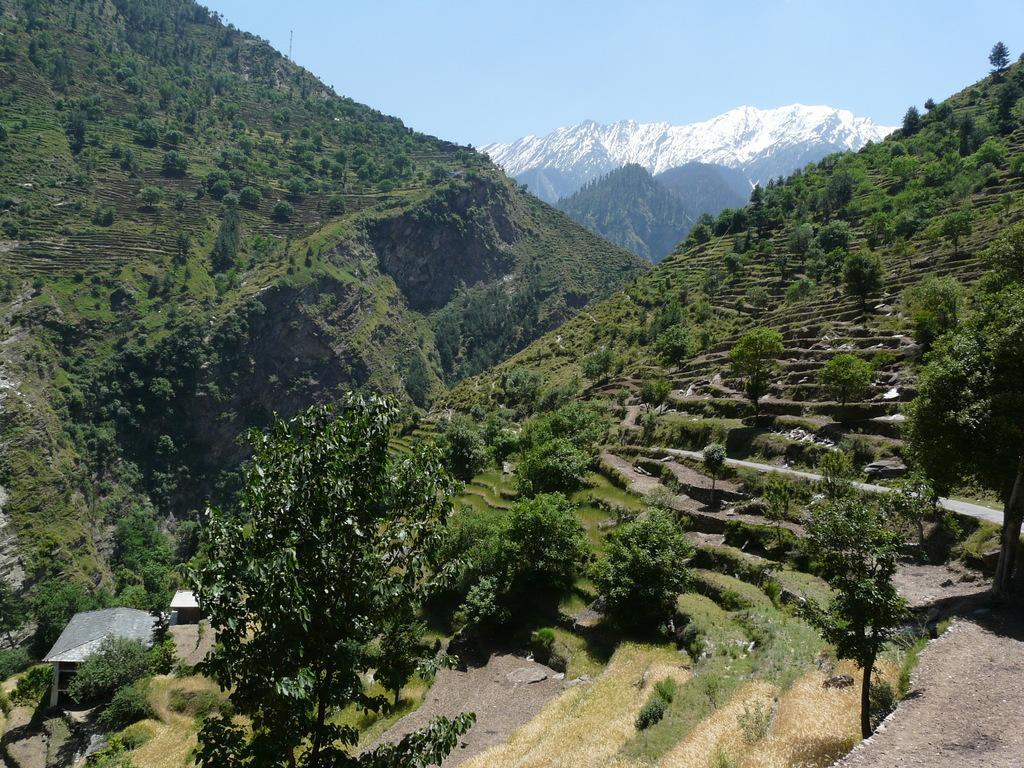Describe this image in one or two sentences. In this image I can see many trees and plants. To the left I can see the sheds. In the background I can see the mountains and the sky. 